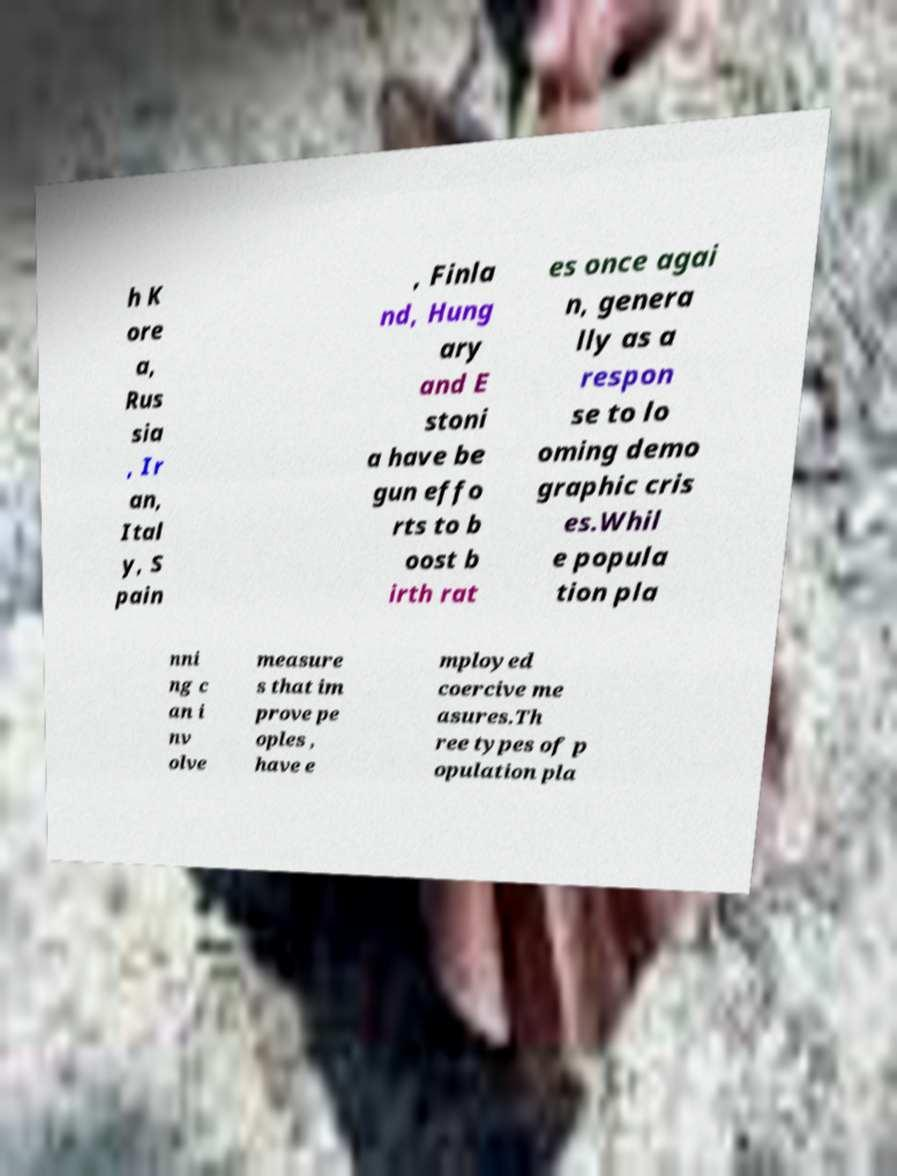Can you read and provide the text displayed in the image?This photo seems to have some interesting text. Can you extract and type it out for me? h K ore a, Rus sia , Ir an, Ital y, S pain , Finla nd, Hung ary and E stoni a have be gun effo rts to b oost b irth rat es once agai n, genera lly as a respon se to lo oming demo graphic cris es.Whil e popula tion pla nni ng c an i nv olve measure s that im prove pe oples , have e mployed coercive me asures.Th ree types of p opulation pla 